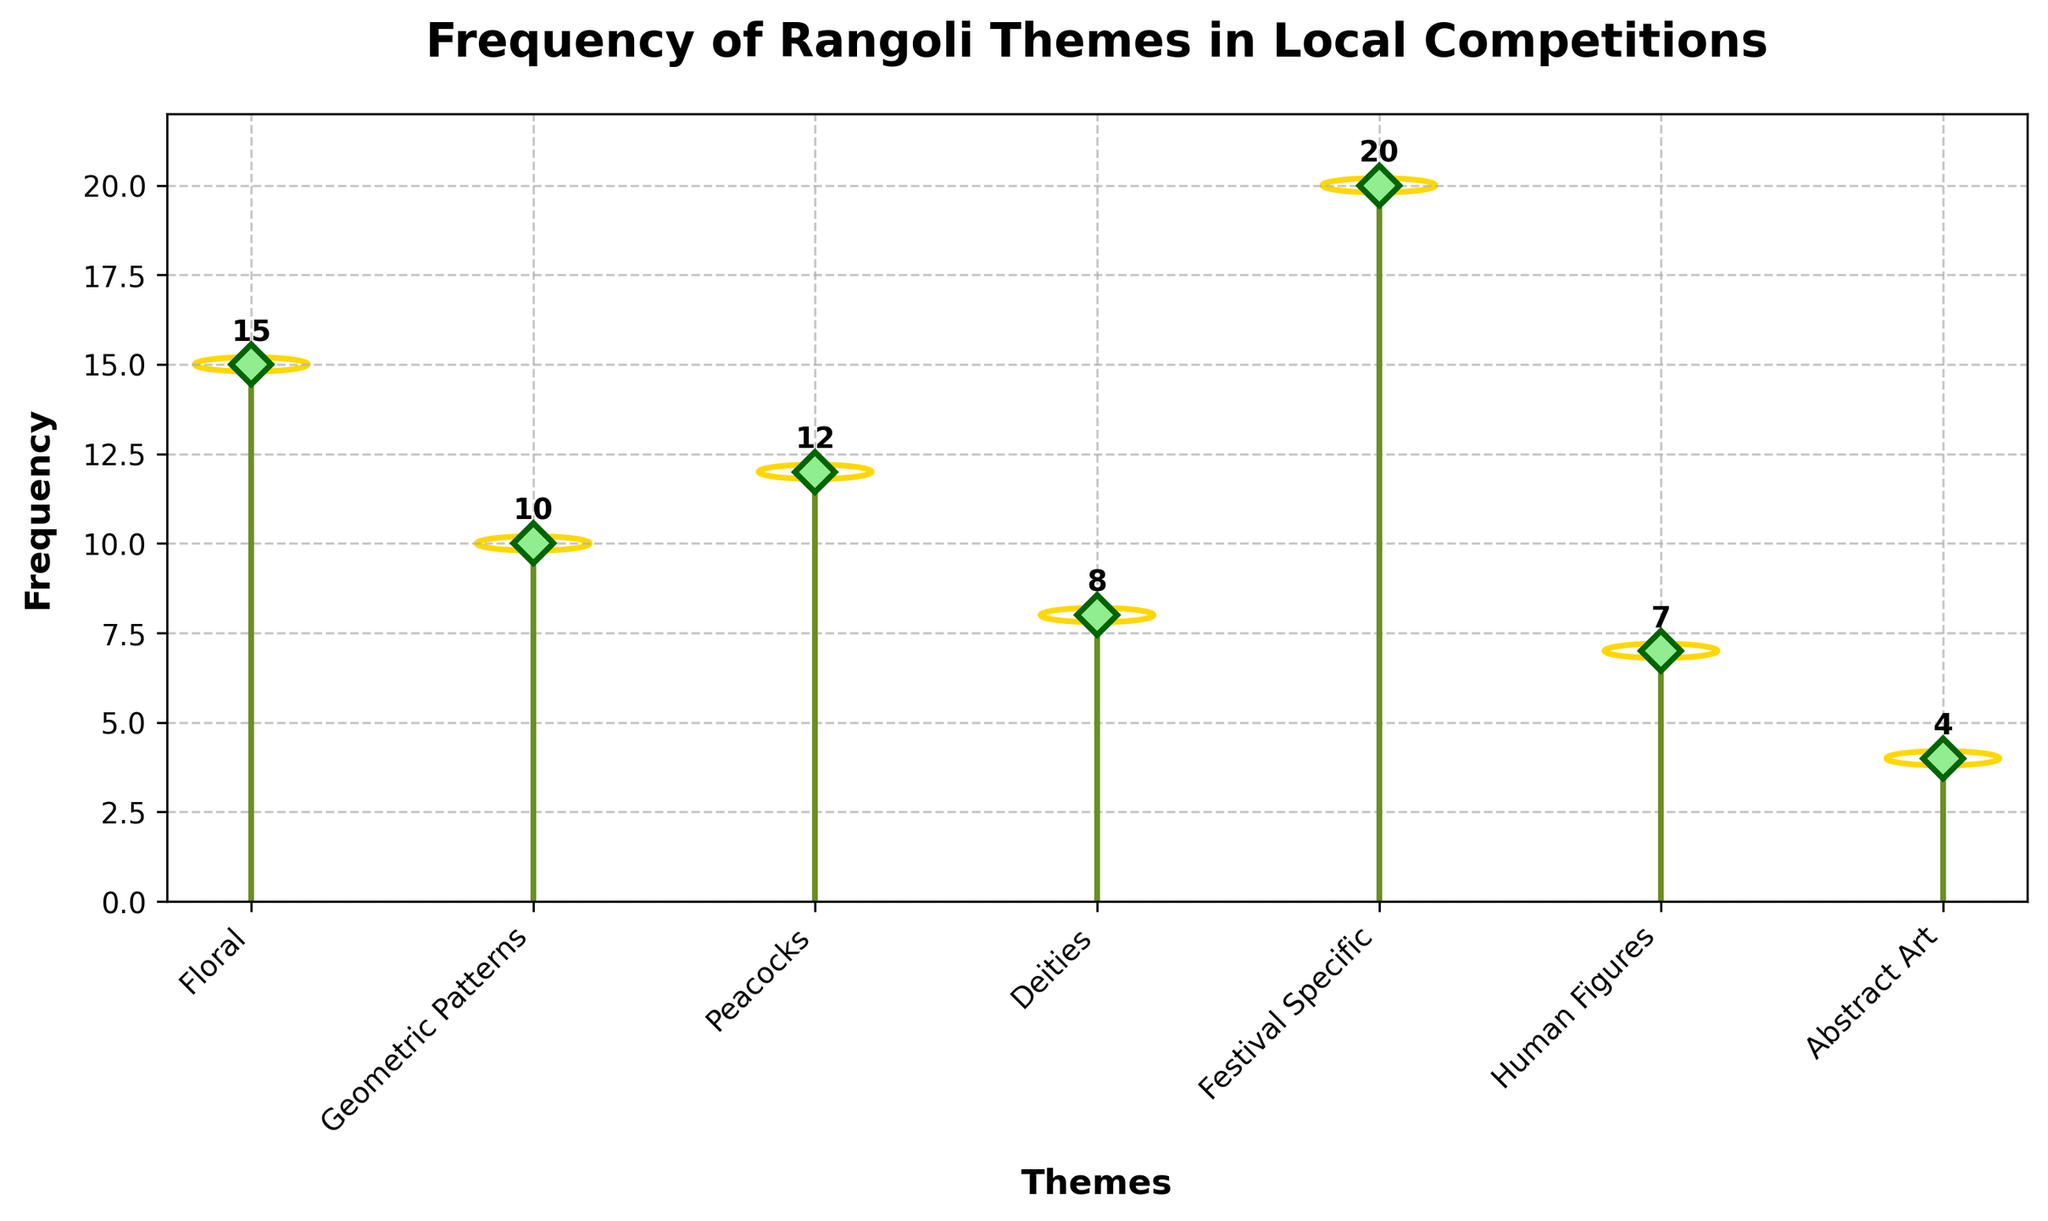What is the most frequently used Rangoli theme in local competitions? The most frequently used theme is identified by the highest frequency value on the plot. Here, the "Festival Specific" theme has the highest frequency value of 20, making it the most frequently used Rangoli theme.
Answer: Festival Specific Which Rangoli theme has the least frequency of use? The least frequently used theme will be the one with the smallest frequency value. From the plot, "Abstract Art" has the lowest frequency, which is 4.
Answer: Abstract Art Compare the frequency of "Geometric Patterns" and "Human Figures." Which one is used more often? By comparing the frequencies of the two themes on the plot, "Geometric Patterns" has a frequency of 10, while "Human Figures" has a frequency of 7. Therefore, "Geometric Patterns" is used more often.
Answer: Geometric Patterns What is the total frequency of the "Floral" and "Peacocks" themes combined? To find the total, add the frequencies of "Floral" and "Peacocks". The stem plot shows 15 for "Floral" and 12 for "Peacocks". So, the total is 15 + 12 = 27.
Answer: 27 How many themes have a frequency higher than 10? By examining the plot, the themes with frequencies higher than 10 are "Floral" (15), "Peacocks" (12), and "Festival Specific" (20). Therefore, there are 3 themes with a frequency higher than 10.
Answer: 3 Which themes have a frequency less than or equal to the frequency of "Deities"? The frequency of "Deities" is 8. Themes with frequencies less than or equal to 8 are "Deities" (8), "Human Figures" (7), and "Abstract Art" (4).
Answer: Deities, Human Figures, Abstract Art What is the average frequency of all the Rangoli themes combined? To find the average frequency, sum the frequencies of all themes and divide by the number of themes. The frequencies are 15, 10, 12, 8, 20, 7, and 4. The sum is 15 + 10 + 12 + 8 + 20 + 7 + 4 = 76. There are 7 themes. So, the average is 76 / 7 ≈ 10.86.
Answer: 10.86 By how much does the frequency of "Festival Specific" exceed the frequency of "Abstract Art"? The frequency of "Festival Specific" is 20, and the frequency of "Abstract Art" is 4. Subtracting these gives 20 - 4 = 16. Therefore, the frequency of "Festival Specific" exceeds "Abstract Art" by 16.
Answer: 16 Which Rangoli theme has a frequency closest to the average frequency of all themes? First, calculate the average frequency, which is approximately 10.86. Then, from the plot, the themes with frequencies closest to 10.86 are "Geometric Patterns" (10) and "Peacocks" (12). The closest one to the average is "Geometric Patterns" with 10.
Answer: Geometric Patterns 